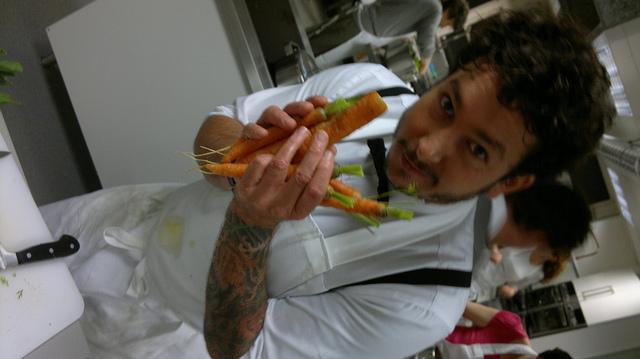Does he have short straight hair?
Keep it brief. No. What is the man's profession?
Short answer required. Chef. What vegetable is the man holding?
Keep it brief. Carrots. 